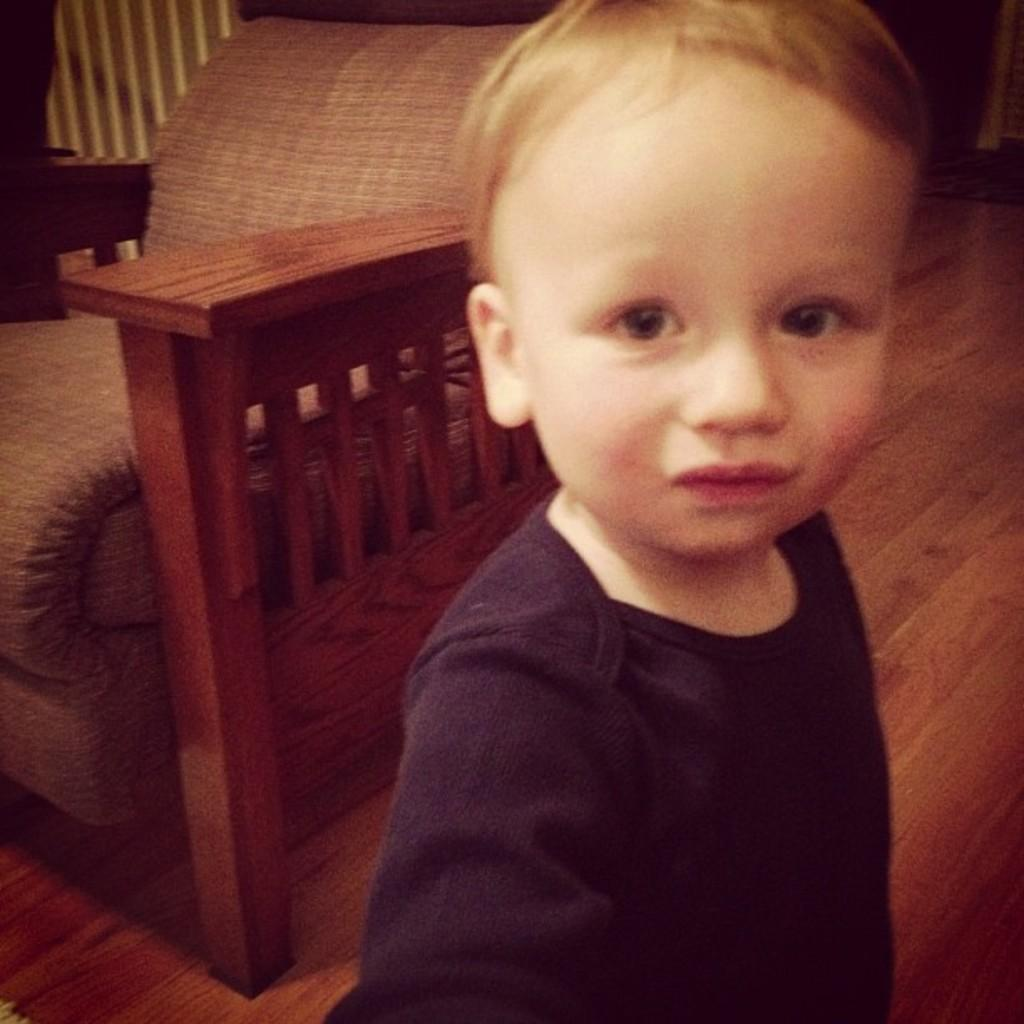What is the main subject of the picture? The main subject of the picture is a kid. What is the kid wearing in the image? The kid is wearing a black t-shirt. Can you describe the object behind the kid? There is a chair behind the kid. What type of juice is the kid drinking in the image? There is no juice present in the image; the kid is not shown drinking anything. 